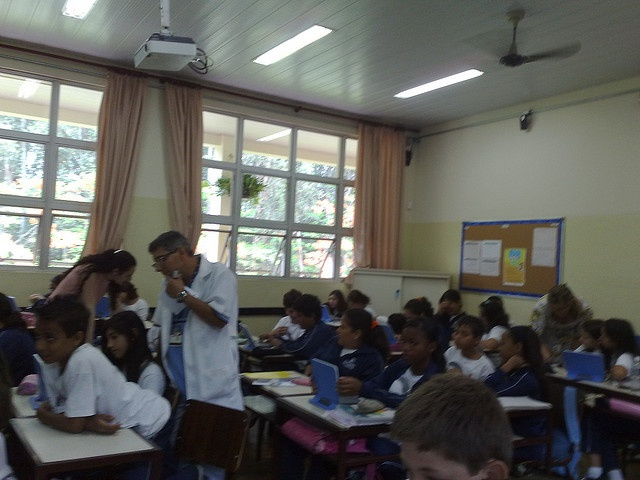Describe the objects in this image and their specific colors. I can see people in lightgray, black, gray, and navy tones, people in lightgray, gray, and black tones, people in lightgray, black, and gray tones, chair in lightgray, black, darkblue, and gray tones, and people in lightgray, black, and gray tones in this image. 